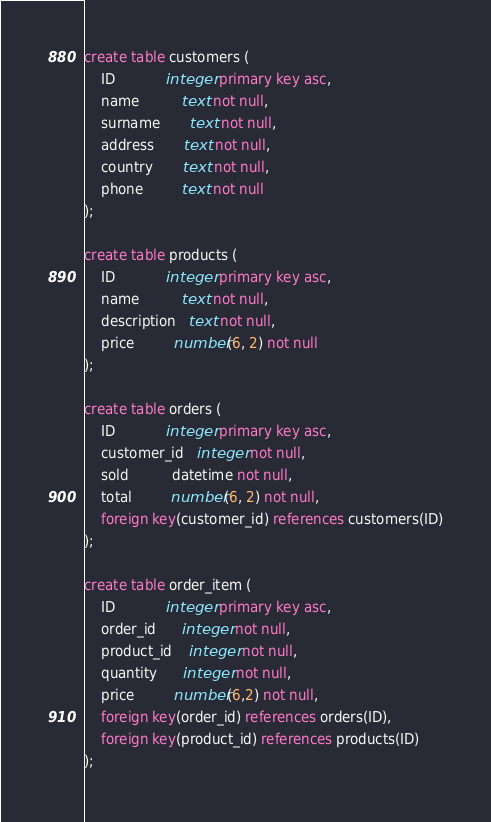<code> <loc_0><loc_0><loc_500><loc_500><_SQL_>create table customers (
    ID            integer primary key asc,
    name          text not null,
    surname       text not null,
    address       text not null,
    country       text not null,
    phone         text not null
);

create table products (
    ID            integer primary key asc,
    name          text not null,
    description   text not null,
    price         number(6, 2) not null
);

create table orders (
    ID            integer primary key asc,
    customer_id   integer not null,
    sold          datetime not null,
    total         number(6, 2) not null,
    foreign key(customer_id) references customers(ID)
);

create table order_item (
    ID            integer primary key asc,
    order_id      integer not null,
    product_id    integer not null,
    quantity      integer not null,
    price         number(6,2) not null,
    foreign key(order_id) references orders(ID),
    foreign key(product_id) references products(ID)
);

</code> 